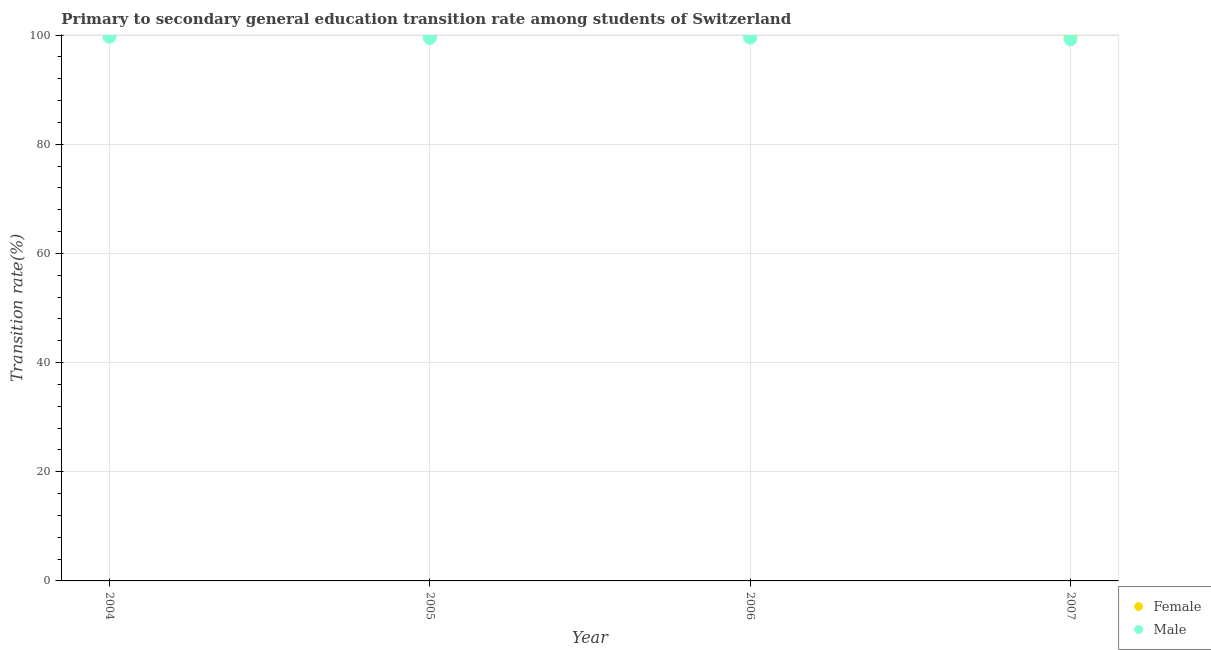What is the transition rate among male students in 2004?
Provide a succinct answer. 99.7. Across all years, what is the maximum transition rate among female students?
Your answer should be compact. 100. Across all years, what is the minimum transition rate among male students?
Ensure brevity in your answer.  99.23. In which year was the transition rate among female students maximum?
Give a very brief answer. 2004. In which year was the transition rate among female students minimum?
Ensure brevity in your answer.  2004. What is the total transition rate among female students in the graph?
Keep it short and to the point. 400. What is the difference between the transition rate among male students in 2007 and the transition rate among female students in 2004?
Your answer should be compact. -0.77. What is the average transition rate among female students per year?
Make the answer very short. 100. In the year 2007, what is the difference between the transition rate among male students and transition rate among female students?
Keep it short and to the point. -0.77. Is the difference between the transition rate among female students in 2004 and 2007 greater than the difference between the transition rate among male students in 2004 and 2007?
Your answer should be very brief. No. What is the difference between the highest and the second highest transition rate among male students?
Offer a very short reply. 0.15. What is the difference between the highest and the lowest transition rate among male students?
Ensure brevity in your answer.  0.46. Is the transition rate among male students strictly greater than the transition rate among female students over the years?
Your response must be concise. No. Is the transition rate among male students strictly less than the transition rate among female students over the years?
Your answer should be very brief. Yes. How many years are there in the graph?
Provide a succinct answer. 4. What is the difference between two consecutive major ticks on the Y-axis?
Ensure brevity in your answer.  20. What is the title of the graph?
Keep it short and to the point. Primary to secondary general education transition rate among students of Switzerland. What is the label or title of the Y-axis?
Your answer should be compact. Transition rate(%). What is the Transition rate(%) of Female in 2004?
Provide a short and direct response. 100. What is the Transition rate(%) in Male in 2004?
Make the answer very short. 99.7. What is the Transition rate(%) in Male in 2005?
Offer a very short reply. 99.47. What is the Transition rate(%) of Female in 2006?
Your answer should be very brief. 100. What is the Transition rate(%) of Male in 2006?
Offer a terse response. 99.54. What is the Transition rate(%) of Male in 2007?
Offer a terse response. 99.23. Across all years, what is the maximum Transition rate(%) in Male?
Offer a terse response. 99.7. Across all years, what is the minimum Transition rate(%) in Female?
Your answer should be very brief. 100. Across all years, what is the minimum Transition rate(%) in Male?
Provide a short and direct response. 99.23. What is the total Transition rate(%) in Female in the graph?
Keep it short and to the point. 400. What is the total Transition rate(%) of Male in the graph?
Your response must be concise. 397.94. What is the difference between the Transition rate(%) of Female in 2004 and that in 2005?
Make the answer very short. 0. What is the difference between the Transition rate(%) of Male in 2004 and that in 2005?
Make the answer very short. 0.22. What is the difference between the Transition rate(%) in Male in 2004 and that in 2006?
Provide a short and direct response. 0.15. What is the difference between the Transition rate(%) of Female in 2004 and that in 2007?
Give a very brief answer. 0. What is the difference between the Transition rate(%) in Male in 2004 and that in 2007?
Your answer should be very brief. 0.46. What is the difference between the Transition rate(%) in Female in 2005 and that in 2006?
Give a very brief answer. 0. What is the difference between the Transition rate(%) in Male in 2005 and that in 2006?
Provide a succinct answer. -0.07. What is the difference between the Transition rate(%) in Female in 2005 and that in 2007?
Give a very brief answer. 0. What is the difference between the Transition rate(%) in Male in 2005 and that in 2007?
Offer a terse response. 0.24. What is the difference between the Transition rate(%) of Male in 2006 and that in 2007?
Keep it short and to the point. 0.31. What is the difference between the Transition rate(%) of Female in 2004 and the Transition rate(%) of Male in 2005?
Make the answer very short. 0.53. What is the difference between the Transition rate(%) in Female in 2004 and the Transition rate(%) in Male in 2006?
Your answer should be very brief. 0.46. What is the difference between the Transition rate(%) of Female in 2004 and the Transition rate(%) of Male in 2007?
Provide a short and direct response. 0.77. What is the difference between the Transition rate(%) in Female in 2005 and the Transition rate(%) in Male in 2006?
Your response must be concise. 0.46. What is the difference between the Transition rate(%) of Female in 2005 and the Transition rate(%) of Male in 2007?
Your answer should be very brief. 0.77. What is the difference between the Transition rate(%) of Female in 2006 and the Transition rate(%) of Male in 2007?
Ensure brevity in your answer.  0.77. What is the average Transition rate(%) in Male per year?
Provide a succinct answer. 99.49. In the year 2004, what is the difference between the Transition rate(%) in Female and Transition rate(%) in Male?
Your response must be concise. 0.3. In the year 2005, what is the difference between the Transition rate(%) in Female and Transition rate(%) in Male?
Your answer should be compact. 0.53. In the year 2006, what is the difference between the Transition rate(%) in Female and Transition rate(%) in Male?
Offer a terse response. 0.46. In the year 2007, what is the difference between the Transition rate(%) of Female and Transition rate(%) of Male?
Your answer should be very brief. 0.77. What is the ratio of the Transition rate(%) of Female in 2004 to that in 2005?
Provide a short and direct response. 1. What is the ratio of the Transition rate(%) in Male in 2004 to that in 2006?
Keep it short and to the point. 1. What is the ratio of the Transition rate(%) of Female in 2004 to that in 2007?
Provide a succinct answer. 1. What is the ratio of the Transition rate(%) in Male in 2004 to that in 2007?
Your answer should be compact. 1. What is the ratio of the Transition rate(%) in Female in 2005 to that in 2006?
Your response must be concise. 1. What is the ratio of the Transition rate(%) of Male in 2005 to that in 2006?
Your answer should be compact. 1. What is the ratio of the Transition rate(%) in Female in 2006 to that in 2007?
Provide a short and direct response. 1. What is the ratio of the Transition rate(%) in Male in 2006 to that in 2007?
Provide a short and direct response. 1. What is the difference between the highest and the second highest Transition rate(%) of Female?
Provide a short and direct response. 0. What is the difference between the highest and the second highest Transition rate(%) of Male?
Make the answer very short. 0.15. What is the difference between the highest and the lowest Transition rate(%) of Female?
Make the answer very short. 0. What is the difference between the highest and the lowest Transition rate(%) of Male?
Keep it short and to the point. 0.46. 